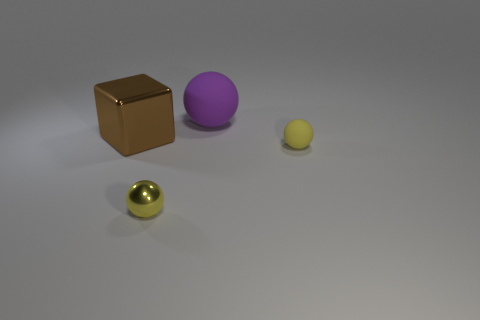Is the size of the yellow metallic object the same as the brown metallic thing? No, the yellow metallic object is smaller in size compared to the brown metallic object. The yellow object appears to be a sphere and the brown object resembles a cube. Each object has distinct geometric shapes and volumes. 